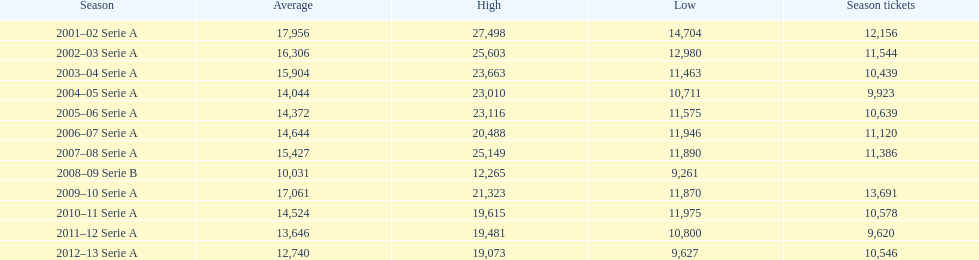What was the average attendance in 2008? 10,031. 